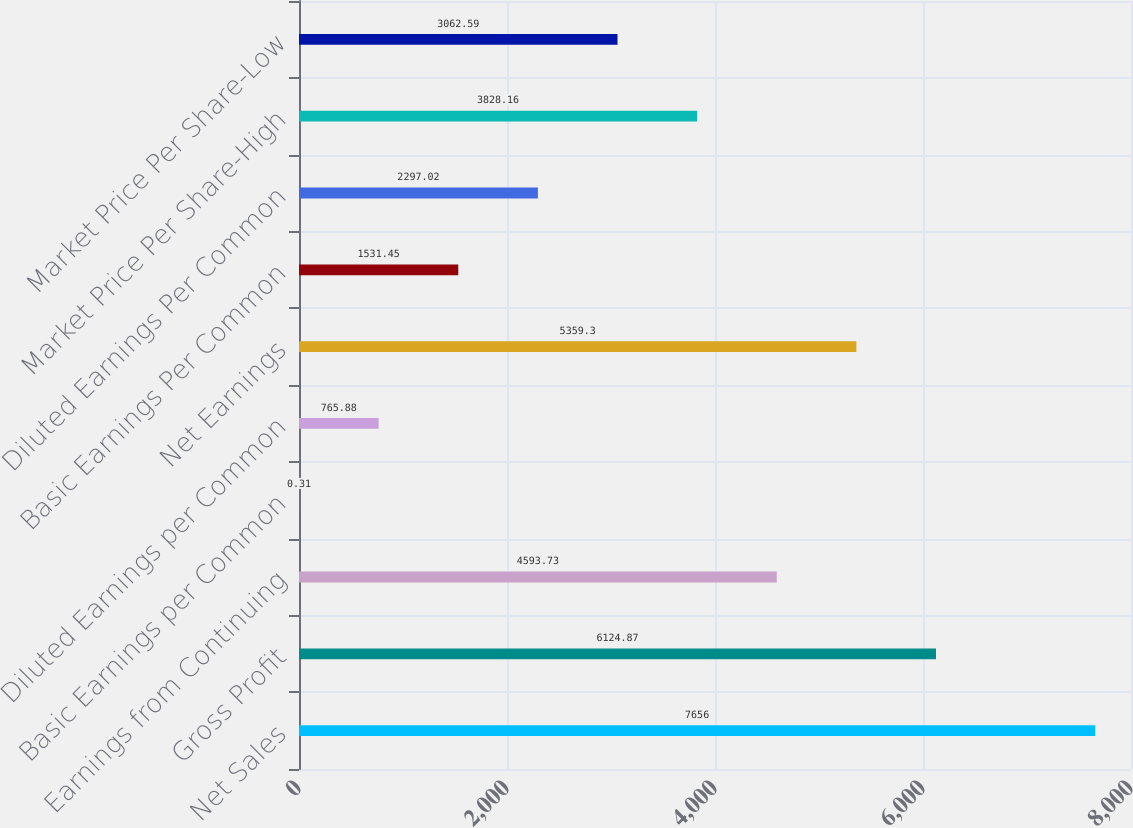<chart> <loc_0><loc_0><loc_500><loc_500><bar_chart><fcel>Net Sales<fcel>Gross Profit<fcel>Earnings from Continuing<fcel>Basic Earnings per Common<fcel>Diluted Earnings per Common<fcel>Net Earnings<fcel>Basic Earnings Per Common<fcel>Diluted Earnings Per Common<fcel>Market Price Per Share-High<fcel>Market Price Per Share-Low<nl><fcel>7656<fcel>6124.87<fcel>4593.73<fcel>0.31<fcel>765.88<fcel>5359.3<fcel>1531.45<fcel>2297.02<fcel>3828.16<fcel>3062.59<nl></chart> 